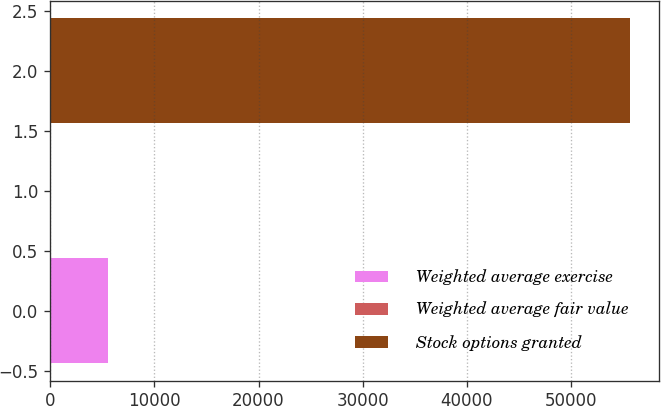Convert chart to OTSL. <chart><loc_0><loc_0><loc_500><loc_500><bar_chart><fcel>Weighted average exercise<fcel>Weighted average fair value<fcel>Stock options granted<nl><fcel>5567.64<fcel>0.93<fcel>55668<nl></chart> 